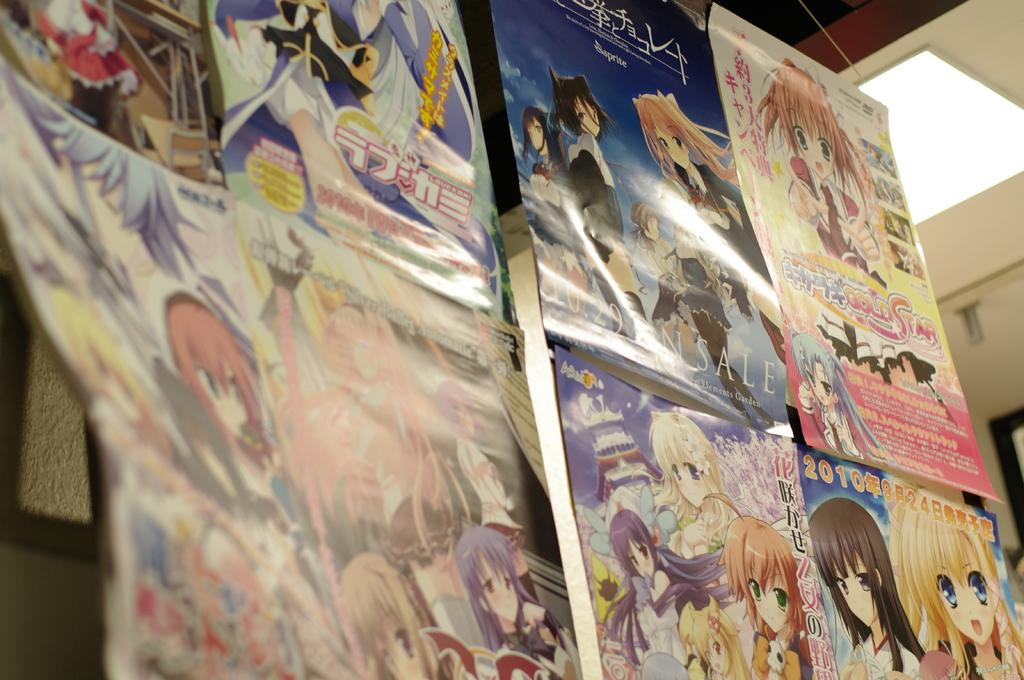Provide a one-sentence caption for the provided image. A collection of anime posters including one with the words "gold star" on it. 